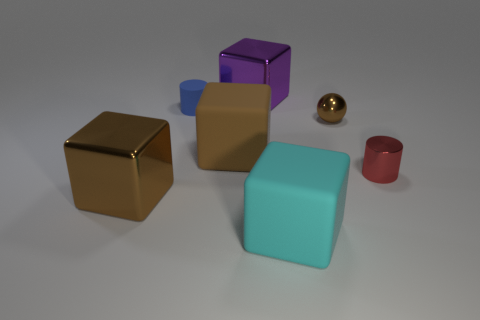Is the ball made of the same material as the big purple thing?
Provide a short and direct response. Yes. The other tiny thing that is the same shape as the tiny red metal thing is what color?
Your answer should be very brief. Blue. Do the large metal block to the left of the small blue object and the ball have the same color?
Provide a succinct answer. Yes. What is the shape of the large metallic object that is the same color as the ball?
Offer a very short reply. Cube. What number of purple cylinders have the same material as the tiny brown thing?
Your answer should be compact. 0. There is a blue rubber cylinder; how many tiny red objects are in front of it?
Provide a short and direct response. 1. What size is the purple metallic block?
Offer a very short reply. Large. What color is the shiny ball that is the same size as the blue matte cylinder?
Ensure brevity in your answer.  Brown. Are there any other cylinders of the same color as the small metallic cylinder?
Ensure brevity in your answer.  No. What is the material of the tiny red cylinder?
Provide a short and direct response. Metal. 